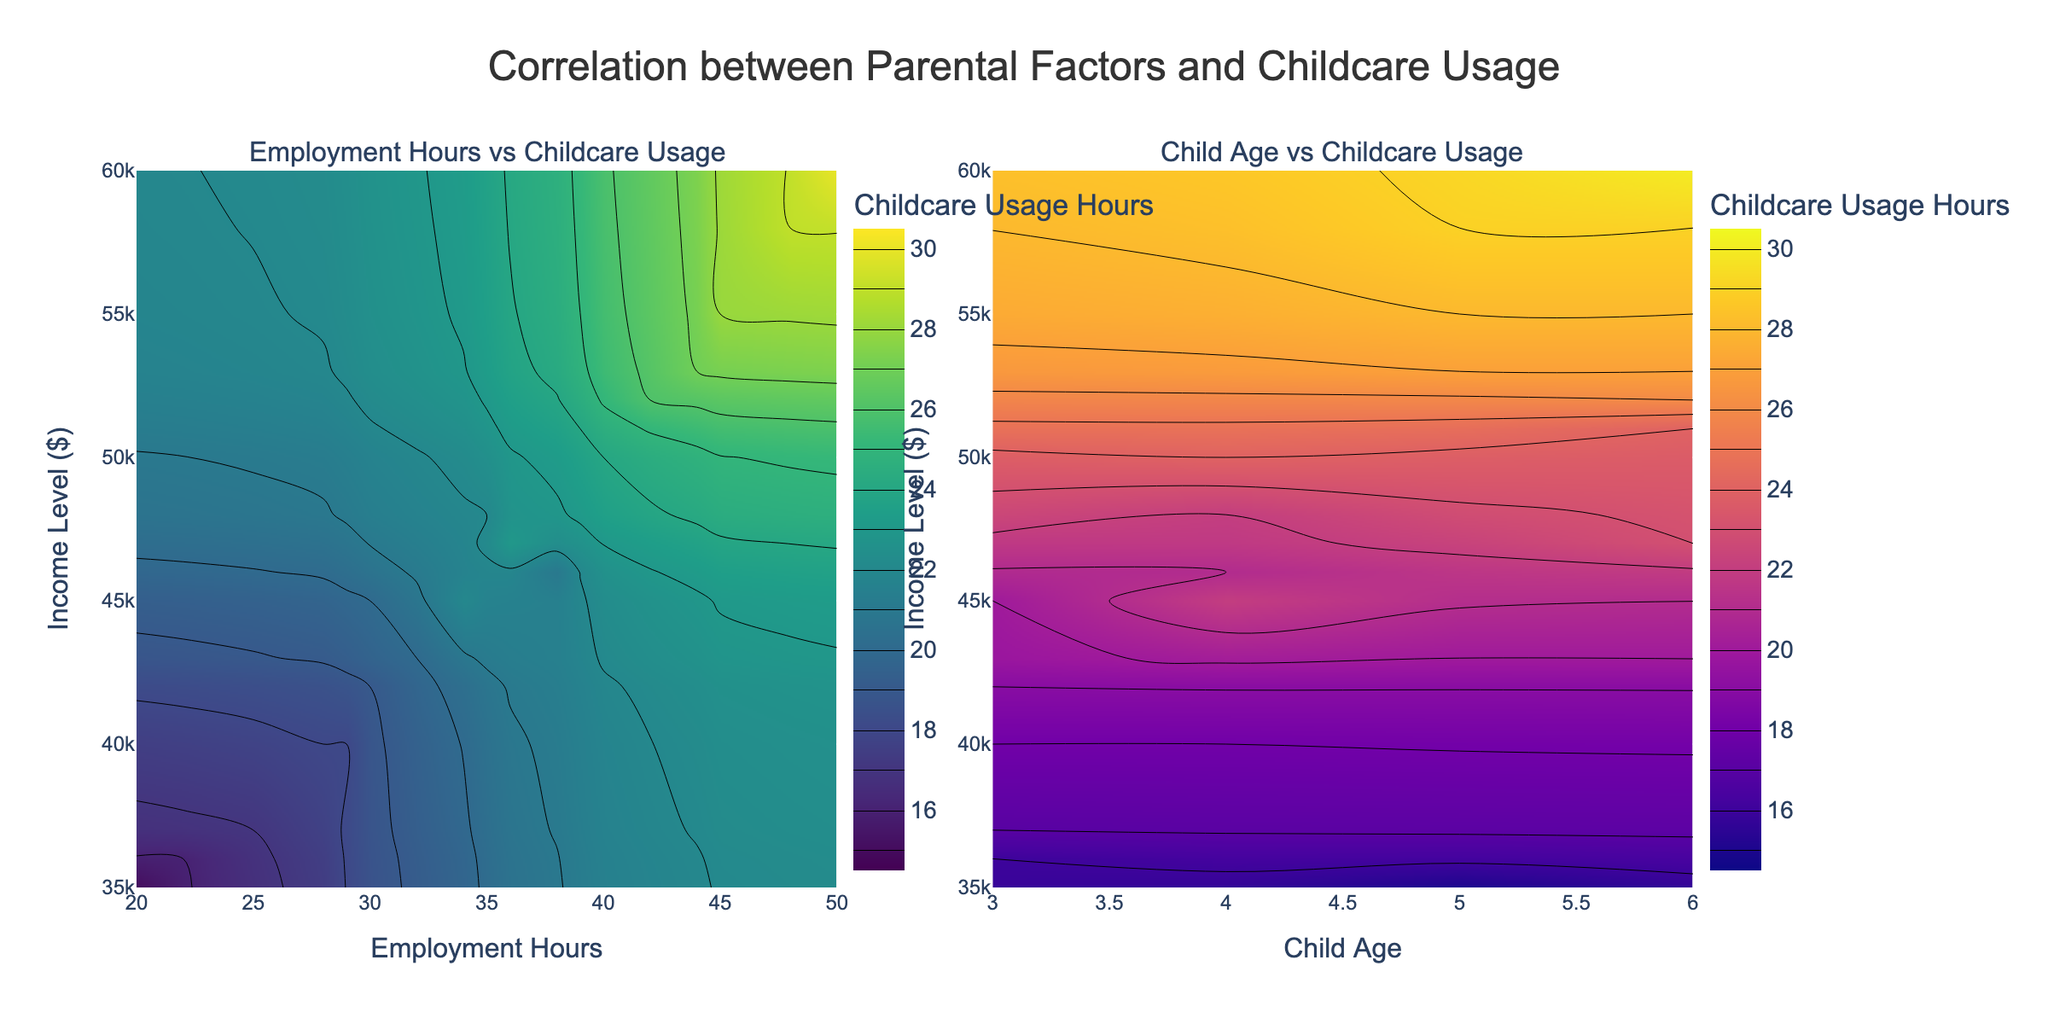What's the title of the figure? The title of the figure is displayed at the top, centered, and states, "Correlation between Parental Factors and Childcare Usage".
Answer: Correlation between Parental Factors and Childcare Usage What are the axes labels in the first subplot? The first subplot has the x-axis labeled "Employment Hours" and the y-axis labeled "Income Level ($)".
Answer: Employment Hours, Income Level ($) What is the color scale used in the first subplot? The color scale used in the first subplot is "Viridis", which ranges from dark blue to bright yellow-green.
Answer: Viridis Which subplot shows a correlation specifically between Child Age and Childcare Usage Hours? The second subplot shows a correlation between Child Age (x-axis) and Childcare Usage Hours (color scale).
Answer: Second subplot How many subplots are present in the figure? The figure is divided into two subplots side by side, each representing different correlations with childcare usage.
Answer: Two What is the range of Childcare Usage Hours in both subplots? Both subplots use a color scale with a range for Childcare Usage Hours between 15 to 30 hours.
Answer: 15 to 30 hours Which subplot color scale uses Plasma colors? The second subplot uses the "Plasma" color scale, ranging from dark purple to bright yellow.
Answer: Second subplot By observing the first subplot, does higher parental employment hours generally correlate with higher childcare usage? In the first subplot, areas with higher employment hours (40 to 50) tend to show brighter colors, indicating higher childcare usage hours, showing a positive correlation.
Answer: Yes In the second subplot, how does child age affect childcare usage hours when income level is constant? When income level is kept constant in the second subplot, as child age increases from 3 to 6, the color intensity indicates a general increase in childcare usage hours.
Answer: Increases Across both subplots, does it appear that income level has an influence on childcare usage? In both subplots, varying color intensity across different income levels suggests that income level may have an influence on childcare usage, but this isn't consistent across all income levels.
Answer: Yes, but inconsistent 